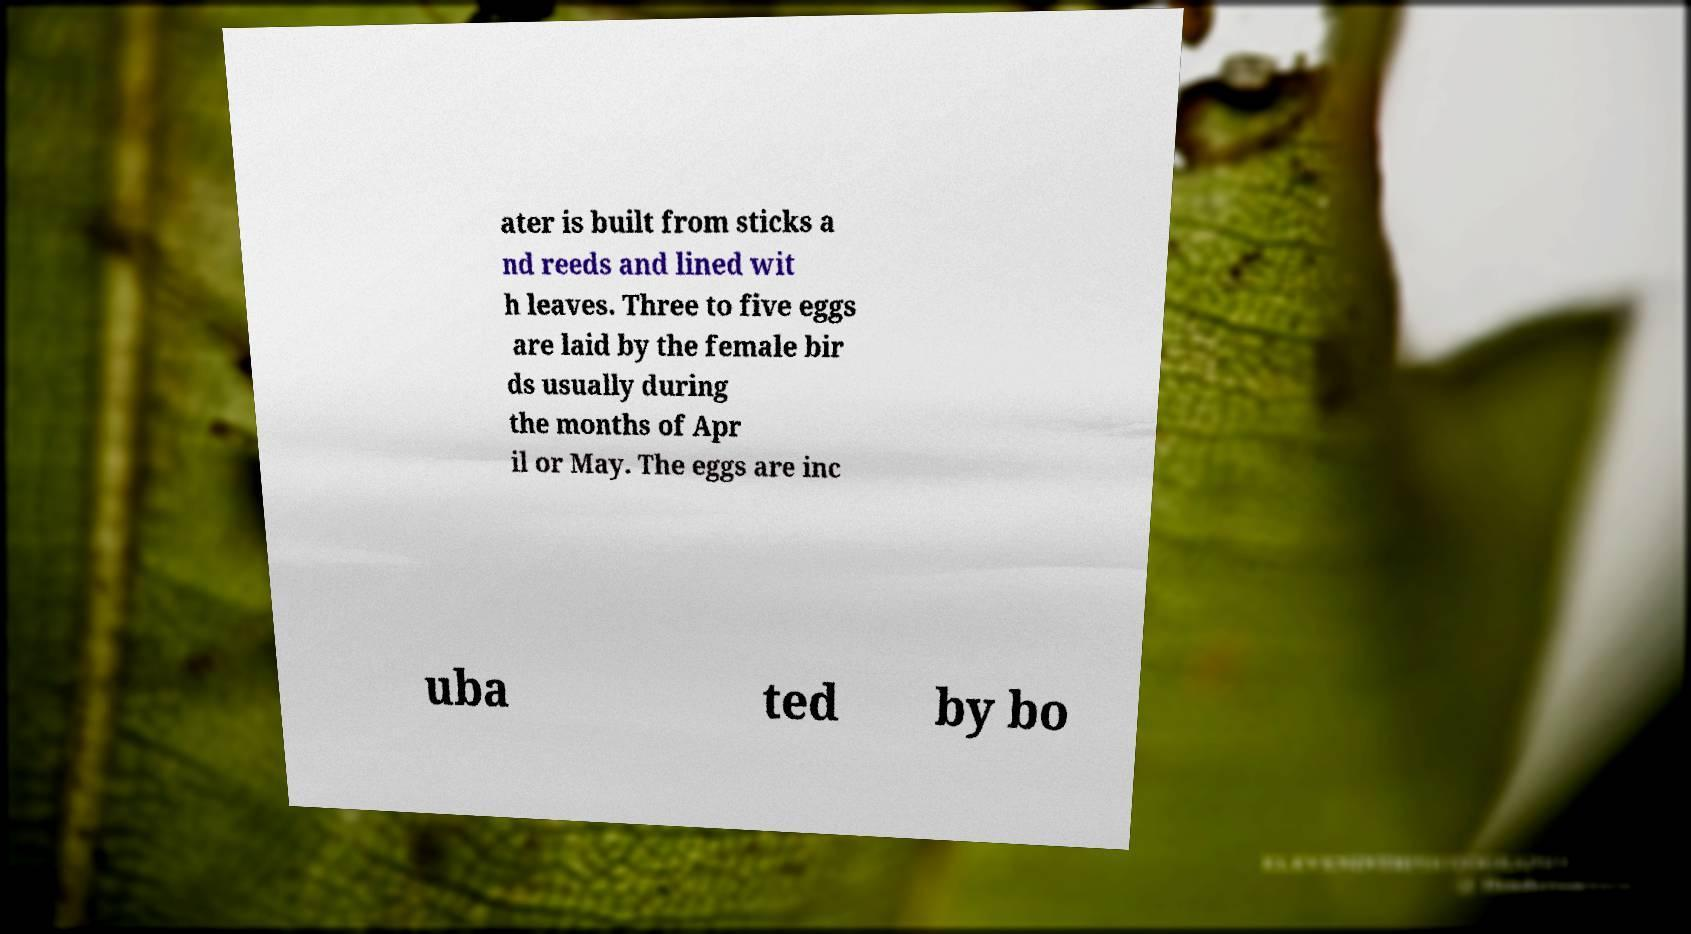I need the written content from this picture converted into text. Can you do that? ater is built from sticks a nd reeds and lined wit h leaves. Three to five eggs are laid by the female bir ds usually during the months of Apr il or May. The eggs are inc uba ted by bo 